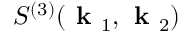<formula> <loc_0><loc_0><loc_500><loc_500>S ^ { ( 3 ) } ( k _ { 1 } , k _ { 2 } )</formula> 